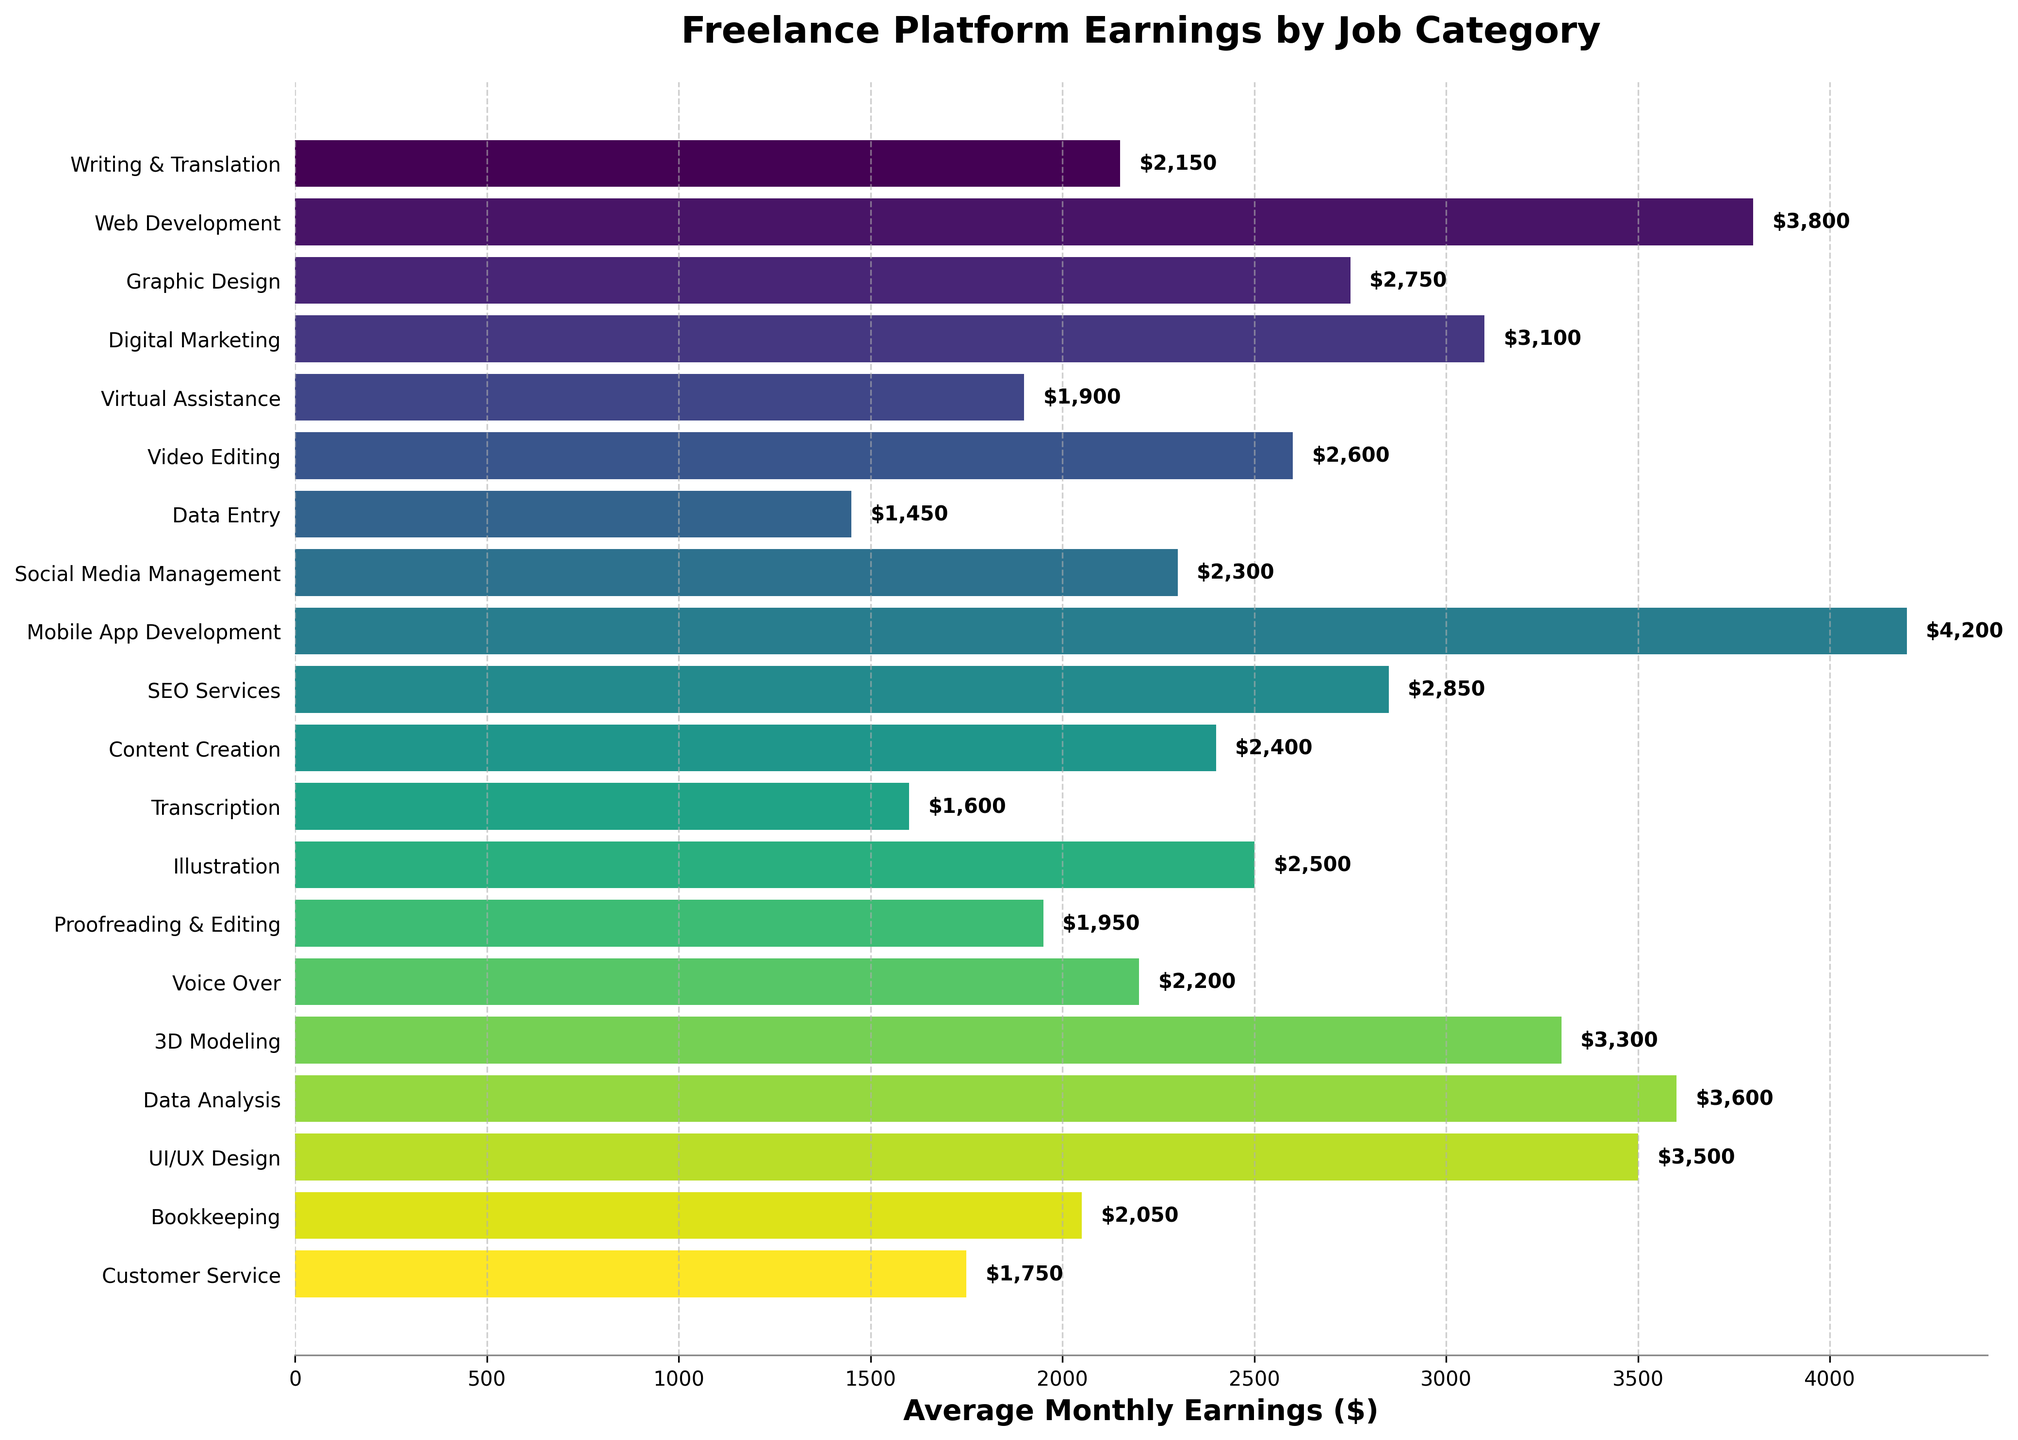Which job category has the highest average monthly earnings? To determine which job category has the highest average monthly earnings, look for the longest bar in the horizontal bar chart. This will represent the job category with the highest value.
Answer: Mobile App Development Which job category has the lowest average monthly earnings? To find the job category with the lowest average monthly earnings, look for the shortest bar in the horizontal bar chart. This will represent the category with the smallest value.
Answer: Data Entry How much more does a Web Developer earn on average than a Virtual Assistant? Find the bar corresponding to Web Development and note its length, which represents average monthly earnings of $3800. Then, find the bar corresponding to Virtual Assistance with earnings of $1900. Subtract the latter from the former: $3800 - $1900.
Answer: $1900 Which job categories earn more than $3000 per month on average? Identify and list the job categories whose bars extend beyond the $3000 mark on the x-axis. These are: Web Development, Digital Marketing, Mobile App Development, SEO Services, Data Analysis, and UI/UX Design.
Answer: Web Development, Digital Marketing, Mobile App Development, SEO Services, Data Analysis, UI/UX Design How do the average monthly earnings of a 3D Modeler compare to those of a Content Creator? Look at the bars for 3D Modeling and Content Creation. 3D Modeling has an average of $3300 while Content Creation has $2400. To compare, note that $3300 is greater than $2400.
Answer: 3D Modeling earns $900 more than Content Creation What is the combined total monthly earnings for Video Editing and Voice Over categories? Find the bars for Video Editing ($2600) and Voice Over ($2200), then add these values together: $2600 + $2200.
Answer: $4800 How much more do Freelancers in Data Analysis earn on average compared to those in Social Media Management? Locate the bars for Data Analysis ($3600) and Social Media Management ($2300). Subtract the latter from the former: $3600 - $2300.
Answer: $1300 What is the median average monthly earnings across all job categories? First, list all the earnings in ascending order: $1450, $1600, $1750, $1900, $1950, $2050, $2150, $2200, $2300, $2400, $2500, $2600, $2750, $2850, $3100, $3300, $3500, $3600, $3800, $4200. Since there are 20 data points, the median is the average of the 10th and 11th values: ($2400 + $2500) / 2.
Answer: $2450 Which category has a closer average monthly earning to $2000: Proofreading & Editing or Bookkeeping? Find the bars for Proofreading & Editing ($1950) and Bookkeeping ($2050). Calculate the absolute difference from $2000 for each: $2000 - $1950 = $50, and $2050 - $2000 = $50. Both have an equal difference of $50 from $2000.
Answer: Both are equally close Is the average monthly earning for Illustration higher or lower than the average for Graphic Design? Compare the bars for Illustration ($2500) and Graphic Design ($2750). Determine if $2500 is less than $2750.
Answer: Lower 